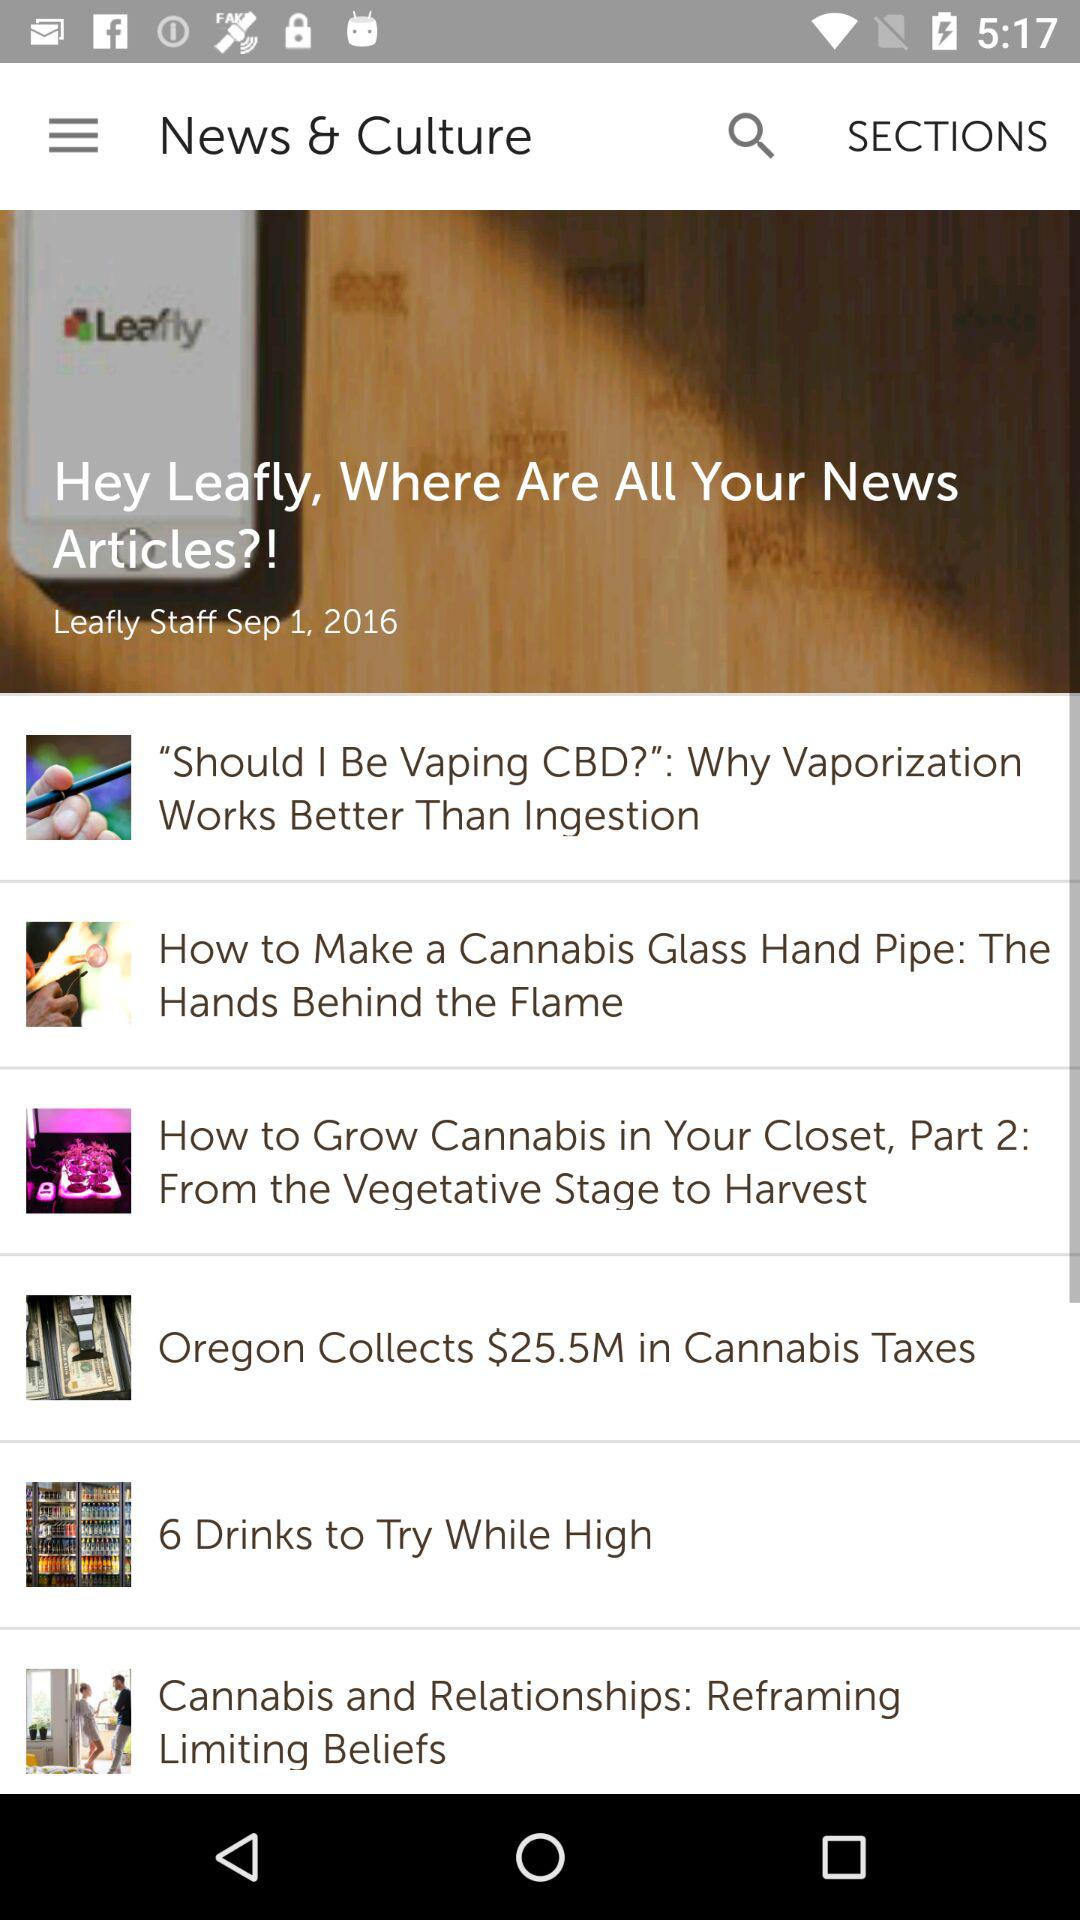What is the name of the article's author? The name of the article's author is Leafly Staff. 